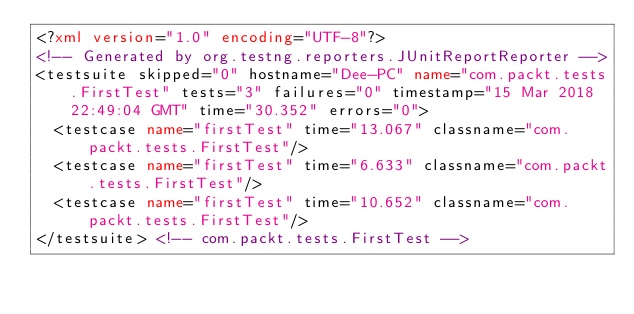<code> <loc_0><loc_0><loc_500><loc_500><_XML_><?xml version="1.0" encoding="UTF-8"?>
<!-- Generated by org.testng.reporters.JUnitReportReporter -->
<testsuite skipped="0" hostname="Dee-PC" name="com.packt.tests.FirstTest" tests="3" failures="0" timestamp="15 Mar 2018 22:49:04 GMT" time="30.352" errors="0">
  <testcase name="firstTest" time="13.067" classname="com.packt.tests.FirstTest"/>
  <testcase name="firstTest" time="6.633" classname="com.packt.tests.FirstTest"/>
  <testcase name="firstTest" time="10.652" classname="com.packt.tests.FirstTest"/>
</testsuite> <!-- com.packt.tests.FirstTest -->
</code> 